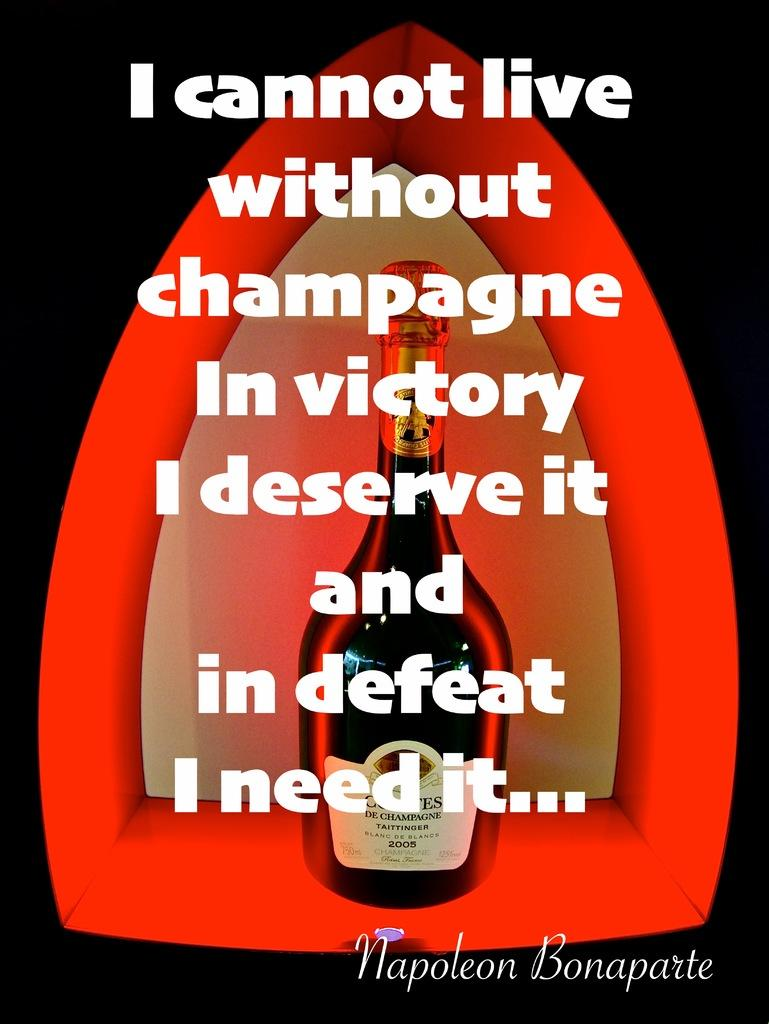<image>
Offer a succinct explanation of the picture presented. A bottle of cognac is seen behind a famous Napoleon quote regarding champagne. 